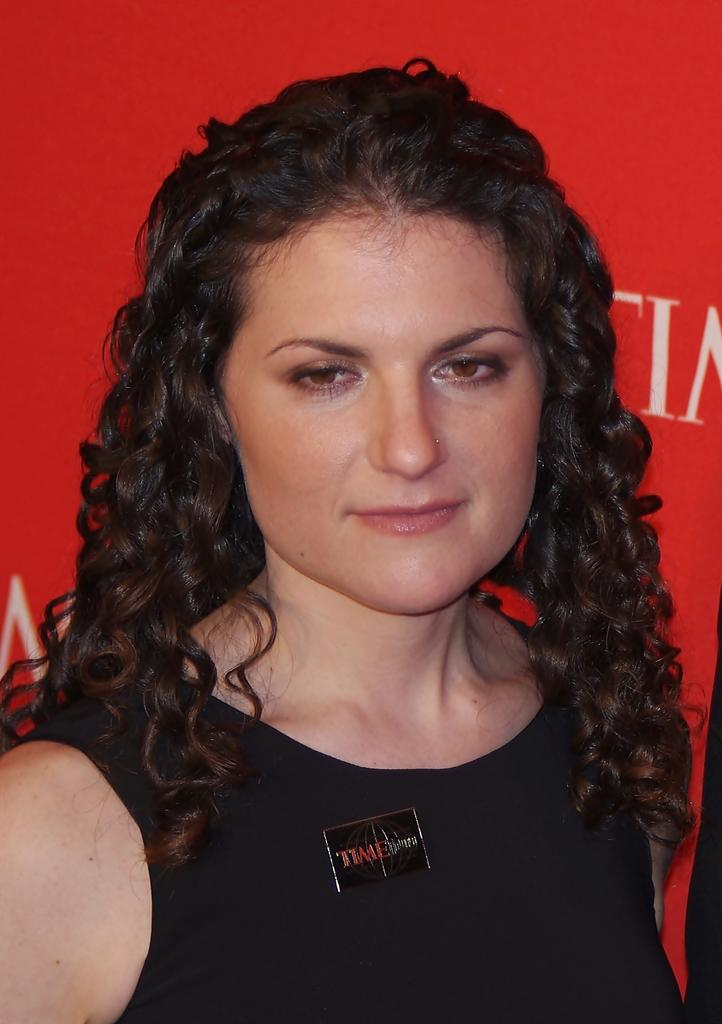Who is present in the image? There is a lady in the image. What can be seen in the background of the image? There is a banner in the background of the image. What is written or depicted on the banner? There is text on the banner. What type of horn can be seen on the lady's head in the image? There is no horn present on the lady's head in the image. What is inside the jar that the lady is holding in the image? The lady is not holding a jar in the image. 